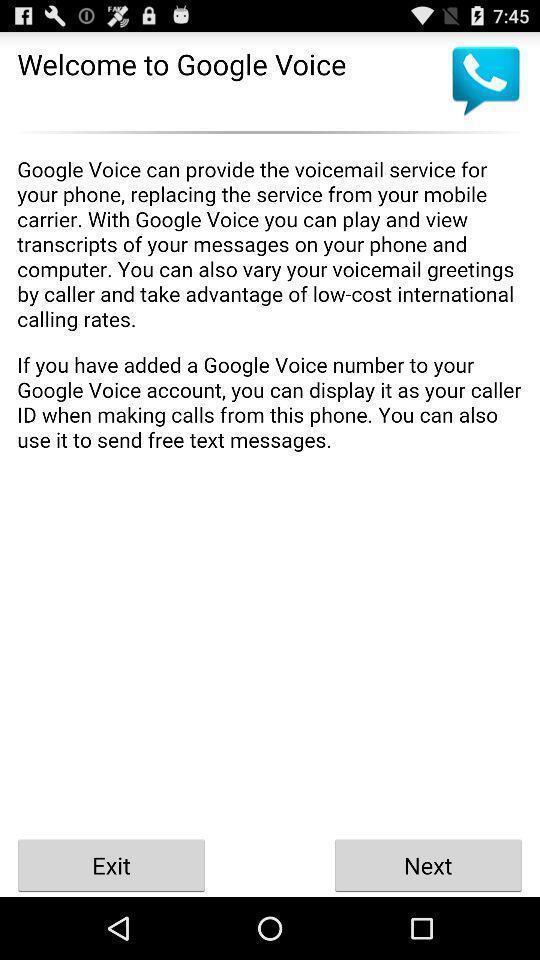Please provide a description for this image. Welcome page. 